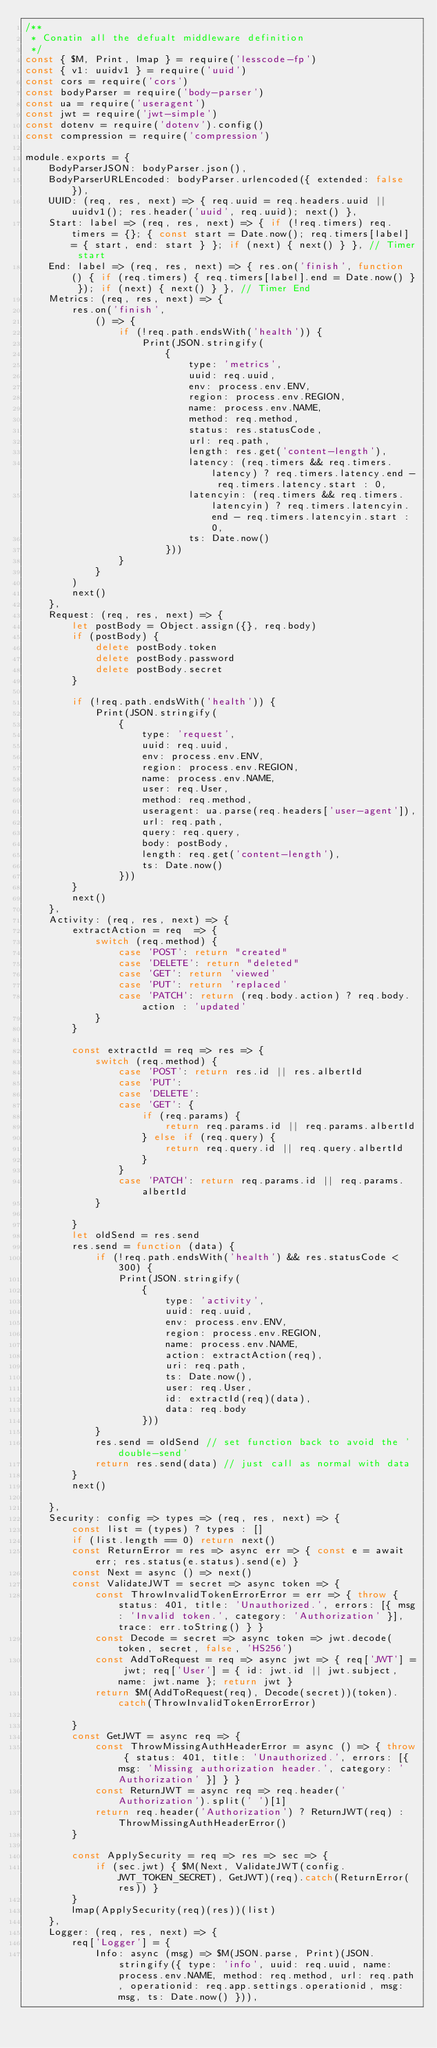<code> <loc_0><loc_0><loc_500><loc_500><_JavaScript_>/**
 * Conatin all the defualt middleware definition
 */
const { $M, Print, lmap } = require('lesscode-fp')
const { v1: uuidv1 } = require('uuid')
const cors = require('cors')
const bodyParser = require('body-parser')
const ua = require('useragent')
const jwt = require('jwt-simple')
const dotenv = require('dotenv').config()
const compression = require('compression')

module.exports = {
    BodyParserJSON: bodyParser.json(),
    BodyParserURLEncoded: bodyParser.urlencoded({ extended: false }),
    UUID: (req, res, next) => { req.uuid = req.headers.uuid || uuidv1(); res.header('uuid', req.uuid); next() },
    Start: label => (req, res, next) => { if (!req.timers) req.timers = {}; { const start = Date.now(); req.timers[label] = { start, end: start } }; if (next) { next() } }, // Timer start
    End: label => (req, res, next) => { res.on('finish', function () { if (req.timers) { req.timers[label].end = Date.now() } }); if (next) { next() } }, // Timer End
    Metrics: (req, res, next) => {
        res.on('finish',
            () => {
                if (!req.path.endsWith('health')) {
                    Print(JSON.stringify(
                        {
                            type: 'metrics',
                            uuid: req.uuid,
                            env: process.env.ENV,
                            region: process.env.REGION,
                            name: process.env.NAME,
                            method: req.method,
                            status: res.statusCode,
                            url: req.path,
                            length: res.get('content-length'),
                            latency: (req.timers && req.timers.latency) ? req.timers.latency.end - req.timers.latency.start : 0,
                            latencyin: (req.timers && req.timers.latencyin) ? req.timers.latencyin.end - req.timers.latencyin.start : 0,
                            ts: Date.now()
                        }))
                }
            }
        )
        next()
    },
    Request: (req, res, next) => {
        let postBody = Object.assign({}, req.body)
        if (postBody) {
            delete postBody.token
            delete postBody.password
            delete postBody.secret
        }

        if (!req.path.endsWith('health')) {
            Print(JSON.stringify(
                {
                    type: 'request',
                    uuid: req.uuid,
                    env: process.env.ENV,
                    region: process.env.REGION,
                    name: process.env.NAME,
                    user: req.User,
                    method: req.method,
                    useragent: ua.parse(req.headers['user-agent']),
                    url: req.path,
                    query: req.query,
                    body: postBody,
                    length: req.get('content-length'),
                    ts: Date.now()
                }))
        }
        next()
    },
    Activity: (req, res, next) => {
        extractAction = req  => {
            switch (req.method) {
                case 'POST': return "created"
                case 'DELETE': return "deleted"
                case 'GET': return 'viewed'
                case 'PUT': return 'replaced'
                case 'PATCH': return (req.body.action) ? req.body.action : 'updated'
            }
        }

        const extractId = req => res => {
            switch (req.method) {
                case 'POST': return res.id || res.albertId
                case 'PUT':
                case 'DELETE':
                case 'GET': {
                    if (req.params) {
                        return req.params.id || req.params.albertId
                    } else if (req.query) {
                        return req.query.id || req.query.albertId
                    }
                }
                case 'PATCH': return req.params.id || req.params.albertId
            }

        }
        let oldSend = res.send
        res.send = function (data) {
            if (!req.path.endsWith('health') && res.statusCode < 300) {
                Print(JSON.stringify(
                    {
                        type: 'activity',
                        uuid: req.uuid,
                        env: process.env.ENV,
                        region: process.env.REGION,
                        name: process.env.NAME,
                        action: extractAction(req),
                        uri: req.path,
                        ts: Date.now(),
                        user: req.User,
                        id: extractId(req)(data),
                        data: req.body
                    }))
            }
            res.send = oldSend // set function back to avoid the 'double-send'
            return res.send(data) // just call as normal with data
        }
        next()

    },
    Security: config => types => (req, res, next) => {
        const list = (types) ? types : []
        if (list.length == 0) return next()
        const ReturnError = res => async err => { const e = await err; res.status(e.status).send(e) }
        const Next = async () => next()
        const ValidateJWT = secret => async token => {
            const ThrowInvalidTokenErrorError = err => { throw { status: 401, title: 'Unauthorized.', errors: [{ msg: 'Invalid token.', category: 'Authorization' }], trace: err.toString() } }
            const Decode = secret => async token => jwt.decode(token, secret, false, 'HS256')
            const AddToRequest = req => async jwt => { req['JWT'] = jwt; req['User'] = { id: jwt.id || jwt.subject, name: jwt.name }; return jwt }
            return $M(AddToRequest(req), Decode(secret))(token).catch(ThrowInvalidTokenErrorError)

        }
        const GetJWT = async req => {
            const ThrowMissingAuthHeaderError = async () => { throw { status: 401, title: 'Unauthorized.', errors: [{ msg: 'Missing authorization header.', category: 'Authorization' }] } }
            const ReturnJWT = async req => req.header('Authorization').split(' ')[1]
            return req.header('Authorization') ? ReturnJWT(req) : ThrowMissingAuthHeaderError()
        }

        const ApplySecurity = req => res => sec => {
            if (sec.jwt) { $M(Next, ValidateJWT(config.JWT_TOKEN_SECRET), GetJWT)(req).catch(ReturnError(res)) }
        }
        lmap(ApplySecurity(req)(res))(list)
    },
    Logger: (req, res, next) => {
        req['Logger'] = {
            Info: async (msg) => $M(JSON.parse, Print)(JSON.stringify({ type: 'info', uuid: req.uuid, name: process.env.NAME, method: req.method, url: req.path, operationid: req.app.settings.operationid, msg: msg, ts: Date.now() })),</code> 